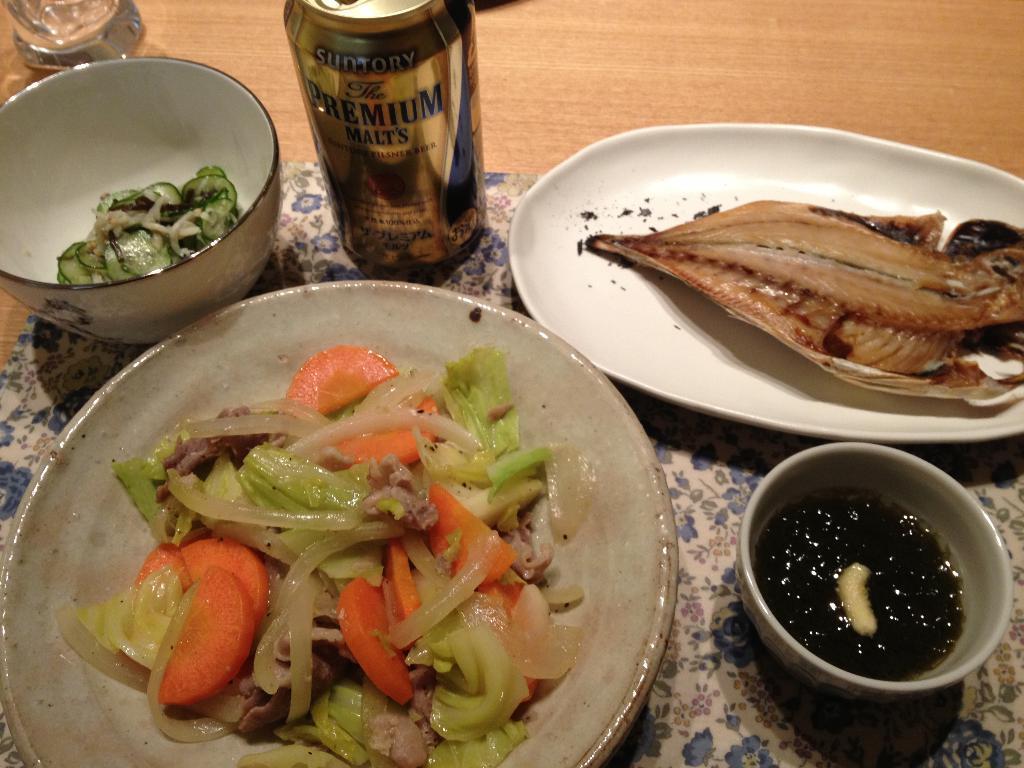Could you give a brief overview of what you see in this image? In this picture I can see food items on plates and bowls. Here I can see a tin can and some other objects on a wooden surface. 